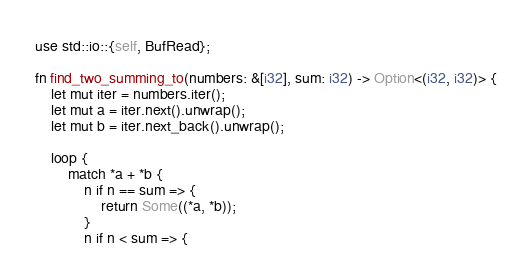<code> <loc_0><loc_0><loc_500><loc_500><_Rust_>use std::io::{self, BufRead};

fn find_two_summing_to(numbers: &[i32], sum: i32) -> Option<(i32, i32)> {
    let mut iter = numbers.iter();
    let mut a = iter.next().unwrap();
    let mut b = iter.next_back().unwrap();

    loop {
        match *a + *b {
            n if n == sum => {
                return Some((*a, *b));
            }
            n if n < sum => {</code> 